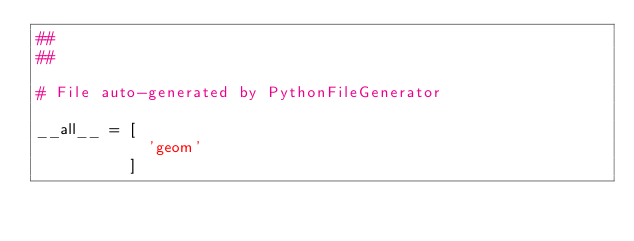<code> <loc_0><loc_0><loc_500><loc_500><_Python_>##
##

# File auto-generated by PythonFileGenerator

__all__ = [
            'geom'
          ]


</code> 